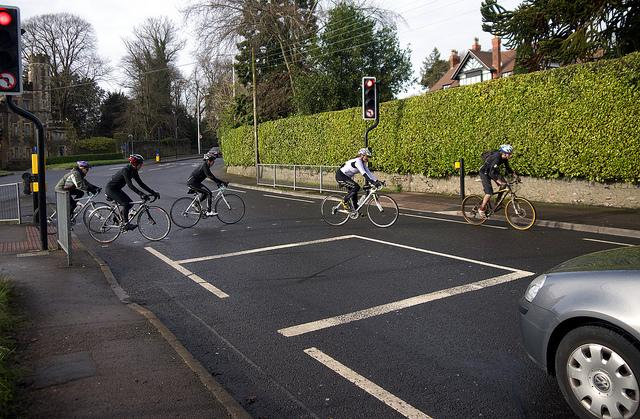If you're in a car coming from this way what is forbidden? Please explain your reasoning. turning left. A car has to yield to the cyclists. they can't run into them. 